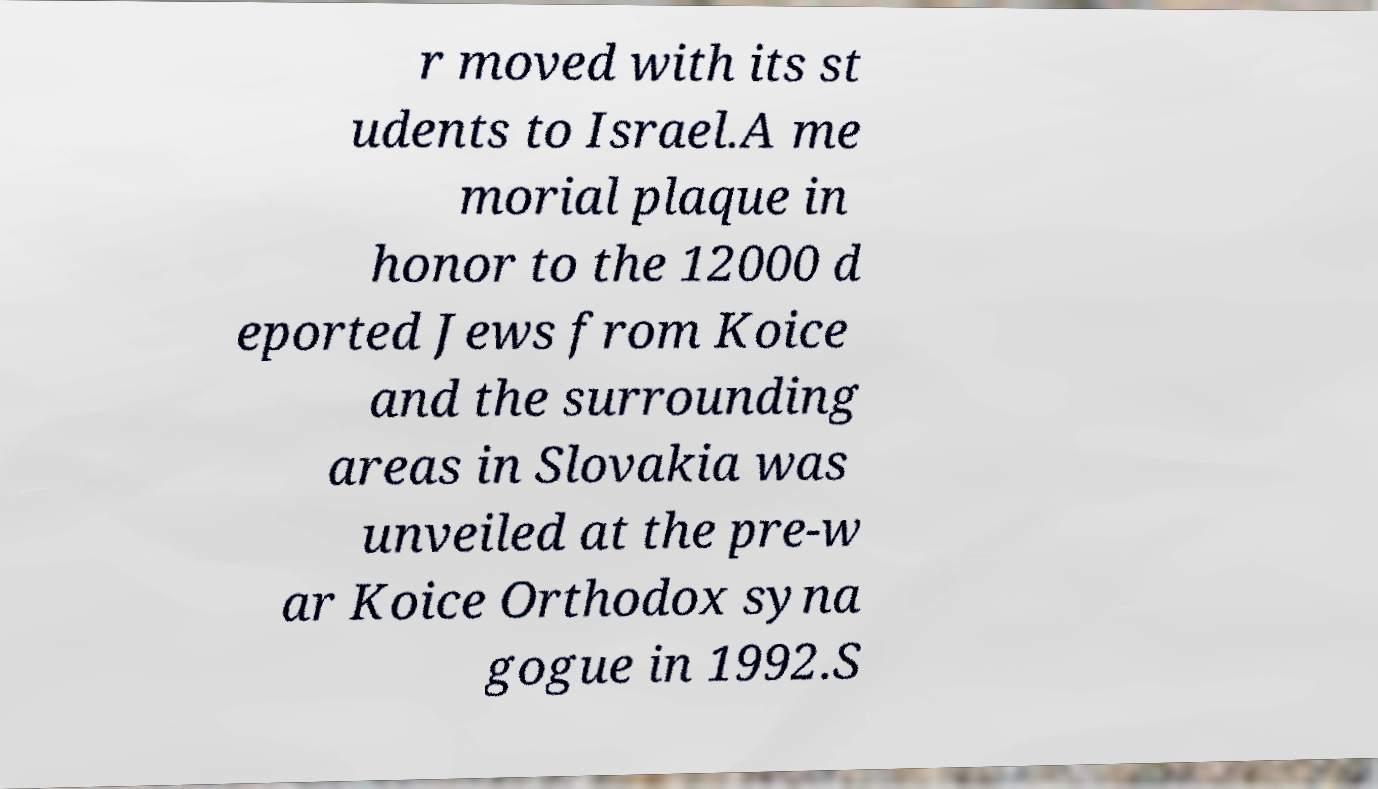Could you extract and type out the text from this image? r moved with its st udents to Israel.A me morial plaque in honor to the 12000 d eported Jews from Koice and the surrounding areas in Slovakia was unveiled at the pre-w ar Koice Orthodox syna gogue in 1992.S 